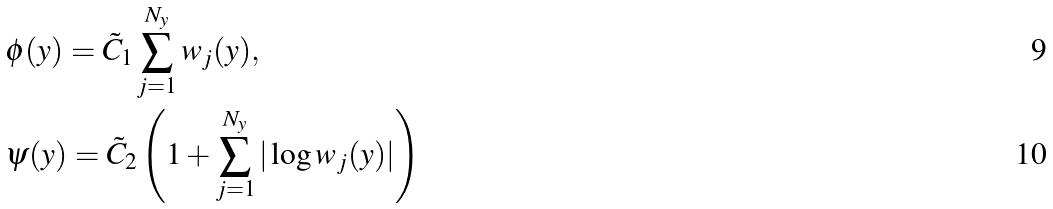<formula> <loc_0><loc_0><loc_500><loc_500>& \phi ( y ) = \tilde { C } _ { 1 } \sum _ { j = 1 } ^ { N _ { y } } w _ { j } ( y ) , \\ & \psi ( y ) = \tilde { C } _ { 2 } \left ( 1 + \sum _ { j = 1 } ^ { N _ { y } } | \log w _ { j } ( y ) | \right )</formula> 